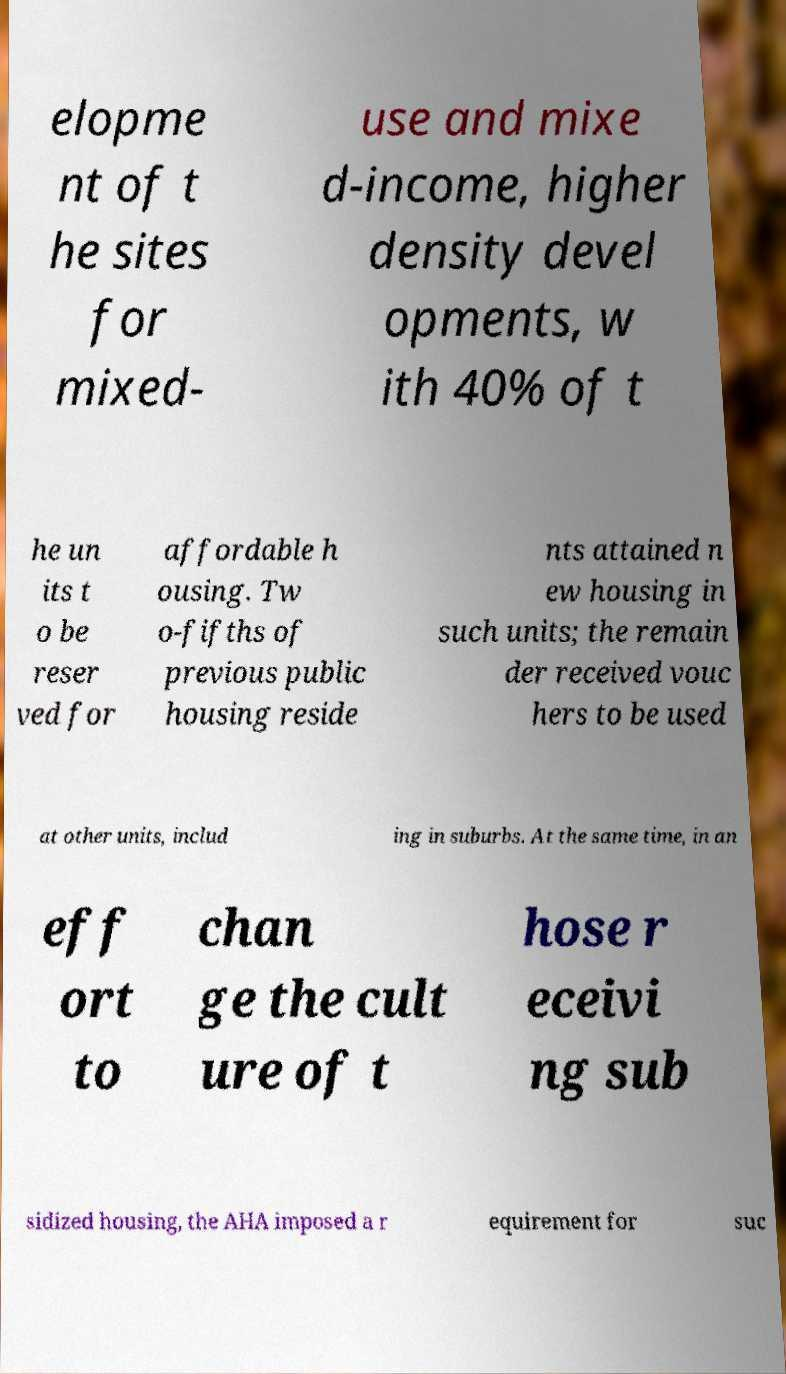Please identify and transcribe the text found in this image. elopme nt of t he sites for mixed- use and mixe d-income, higher density devel opments, w ith 40% of t he un its t o be reser ved for affordable h ousing. Tw o-fifths of previous public housing reside nts attained n ew housing in such units; the remain der received vouc hers to be used at other units, includ ing in suburbs. At the same time, in an eff ort to chan ge the cult ure of t hose r eceivi ng sub sidized housing, the AHA imposed a r equirement for suc 